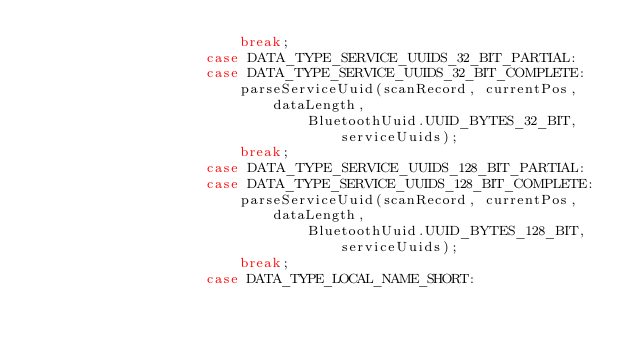<code> <loc_0><loc_0><loc_500><loc_500><_Java_>                        break;
                    case DATA_TYPE_SERVICE_UUIDS_32_BIT_PARTIAL:
                    case DATA_TYPE_SERVICE_UUIDS_32_BIT_COMPLETE:
                        parseServiceUuid(scanRecord, currentPos, dataLength,
                                BluetoothUuid.UUID_BYTES_32_BIT, serviceUuids);
                        break;
                    case DATA_TYPE_SERVICE_UUIDS_128_BIT_PARTIAL:
                    case DATA_TYPE_SERVICE_UUIDS_128_BIT_COMPLETE:
                        parseServiceUuid(scanRecord, currentPos, dataLength,
                                BluetoothUuid.UUID_BYTES_128_BIT, serviceUuids);
                        break;
                    case DATA_TYPE_LOCAL_NAME_SHORT:</code> 